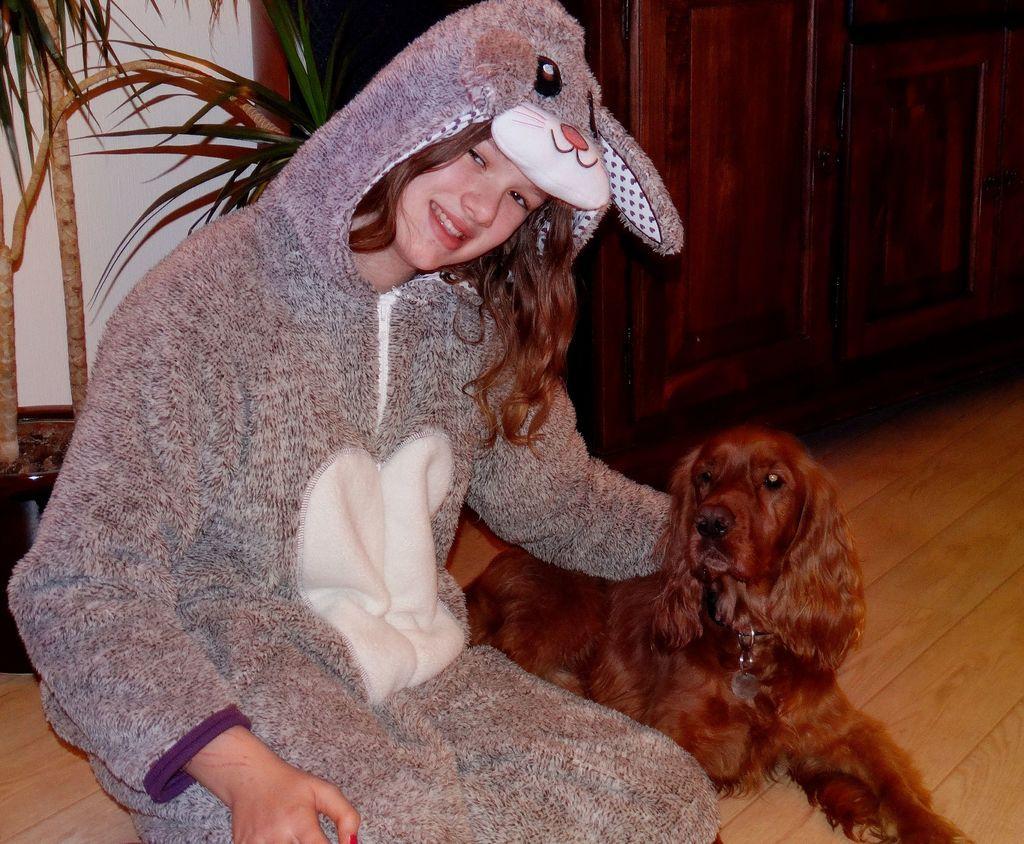Please provide a concise description of this image. Here we can see a girl wearing a costume with a dog beside her and behind her there is plant 